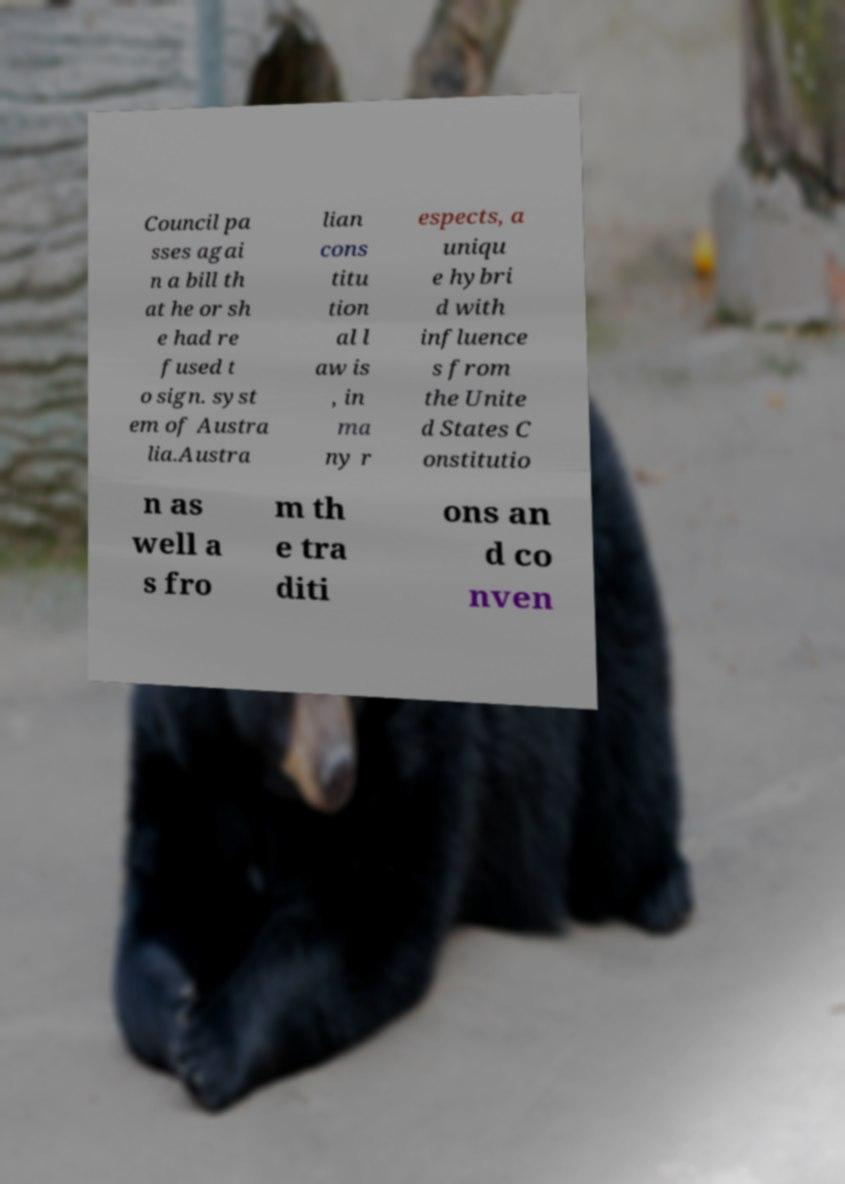Please identify and transcribe the text found in this image. Council pa sses agai n a bill th at he or sh e had re fused t o sign. syst em of Austra lia.Austra lian cons titu tion al l aw is , in ma ny r espects, a uniqu e hybri d with influence s from the Unite d States C onstitutio n as well a s fro m th e tra diti ons an d co nven 